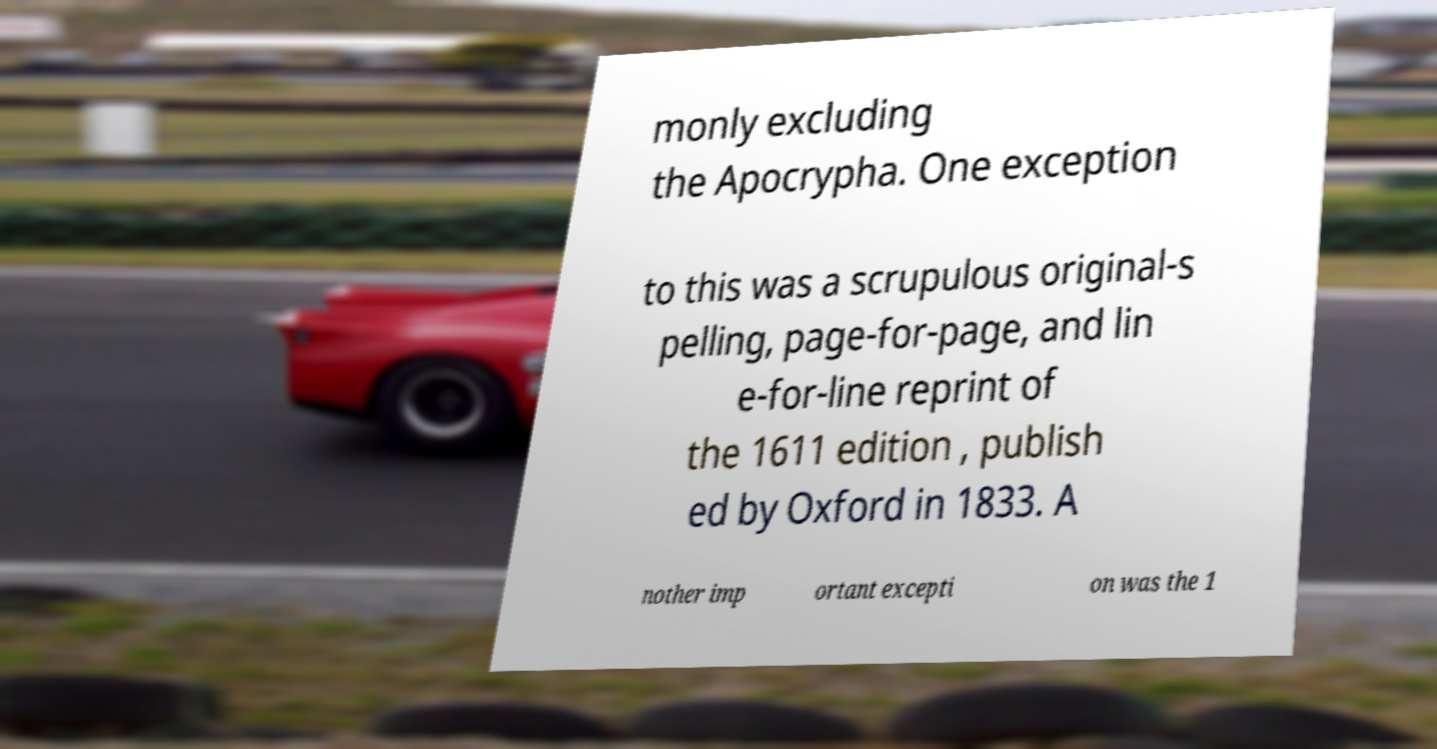Can you read and provide the text displayed in the image?This photo seems to have some interesting text. Can you extract and type it out for me? monly excluding the Apocrypha. One exception to this was a scrupulous original-s pelling, page-for-page, and lin e-for-line reprint of the 1611 edition , publish ed by Oxford in 1833. A nother imp ortant excepti on was the 1 